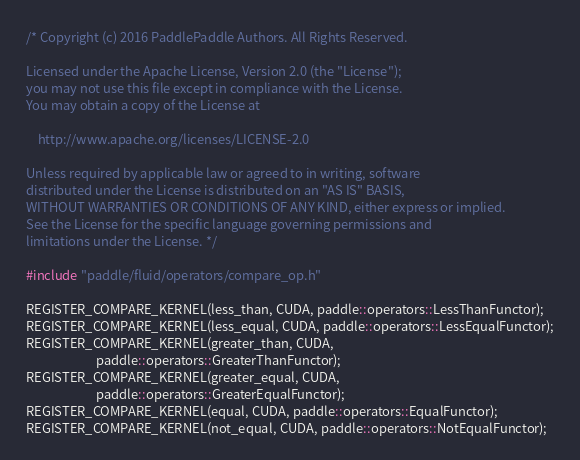<code> <loc_0><loc_0><loc_500><loc_500><_Cuda_>/* Copyright (c) 2016 PaddlePaddle Authors. All Rights Reserved.

Licensed under the Apache License, Version 2.0 (the "License");
you may not use this file except in compliance with the License.
You may obtain a copy of the License at

    http://www.apache.org/licenses/LICENSE-2.0

Unless required by applicable law or agreed to in writing, software
distributed under the License is distributed on an "AS IS" BASIS,
WITHOUT WARRANTIES OR CONDITIONS OF ANY KIND, either express or implied.
See the License for the specific language governing permissions and
limitations under the License. */

#include "paddle/fluid/operators/compare_op.h"

REGISTER_COMPARE_KERNEL(less_than, CUDA, paddle::operators::LessThanFunctor);
REGISTER_COMPARE_KERNEL(less_equal, CUDA, paddle::operators::LessEqualFunctor);
REGISTER_COMPARE_KERNEL(greater_than, CUDA,
                        paddle::operators::GreaterThanFunctor);
REGISTER_COMPARE_KERNEL(greater_equal, CUDA,
                        paddle::operators::GreaterEqualFunctor);
REGISTER_COMPARE_KERNEL(equal, CUDA, paddle::operators::EqualFunctor);
REGISTER_COMPARE_KERNEL(not_equal, CUDA, paddle::operators::NotEqualFunctor);
</code> 